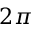Convert formula to latex. <formula><loc_0><loc_0><loc_500><loc_500>2 \pi</formula> 